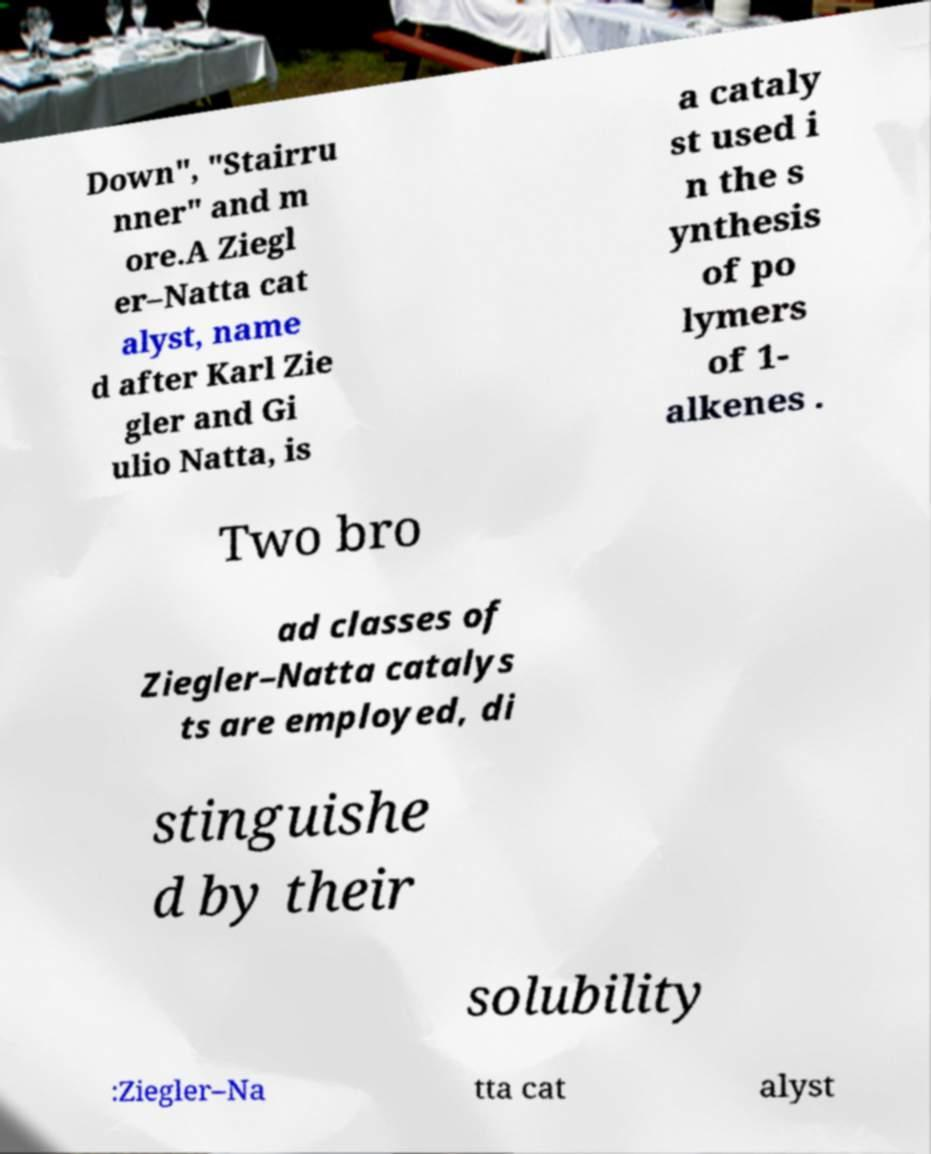Could you extract and type out the text from this image? Down", "Stairru nner" and m ore.A Ziegl er–Natta cat alyst, name d after Karl Zie gler and Gi ulio Natta, is a cataly st used i n the s ynthesis of po lymers of 1- alkenes . Two bro ad classes of Ziegler–Natta catalys ts are employed, di stinguishe d by their solubility :Ziegler–Na tta cat alyst 